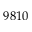Convert formula to latex. <formula><loc_0><loc_0><loc_500><loc_500>9 8 1 0</formula> 